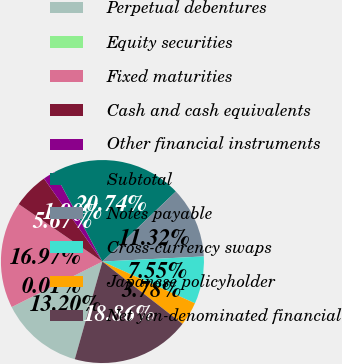Convert chart. <chart><loc_0><loc_0><loc_500><loc_500><pie_chart><fcel>Perpetual debentures<fcel>Equity securities<fcel>Fixed maturities<fcel>Cash and cash equivalents<fcel>Other financial instruments<fcel>Subtotal<fcel>Notes payable<fcel>Cross-currency swaps<fcel>Japanese policyholder<fcel>Net yen-denominated financial<nl><fcel>13.2%<fcel>0.01%<fcel>16.97%<fcel>5.67%<fcel>1.9%<fcel>20.74%<fcel>11.32%<fcel>7.55%<fcel>3.78%<fcel>18.86%<nl></chart> 